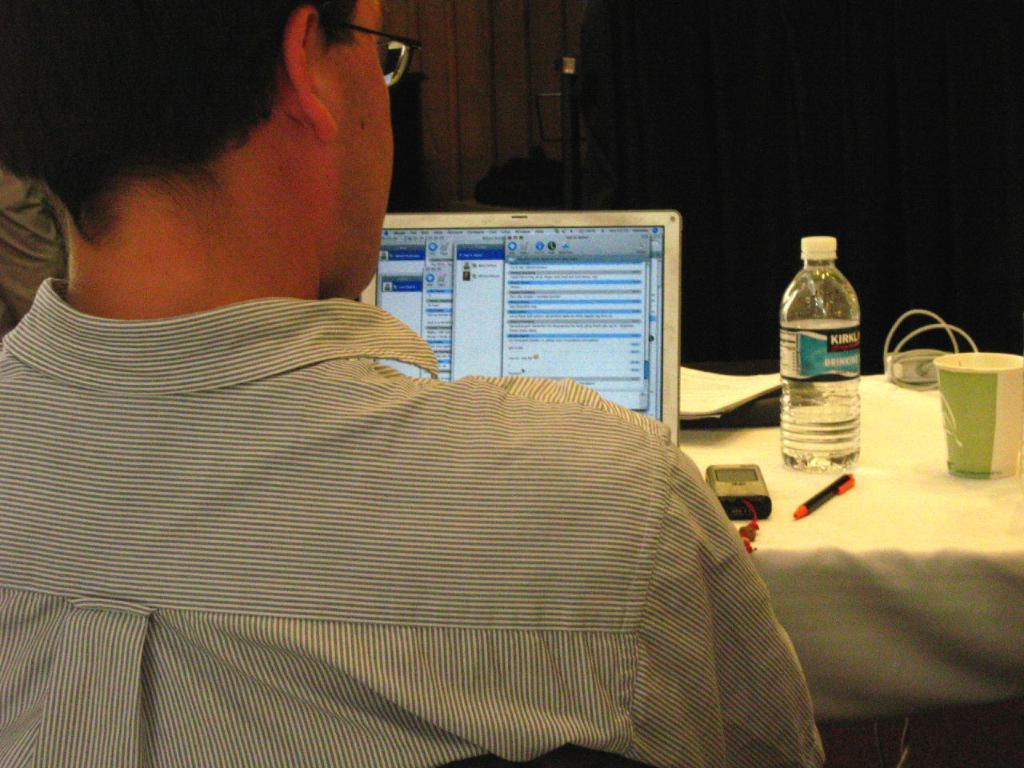What can be seen in the image? There is a person in the image. Can you describe the person's appearance? The person is wearing spectacles. What is the person doing in the image? The person is sitting on a chair. What is on the table in front of the chair? There is a laptop, a bottle, a glass, and a pen on the table. Can you see any ladybugs crawling on the laptop in the image? There are no ladybugs present in the image. Is there a knot tied on the pen in the image? There is no knot tied on the pen in the image. 